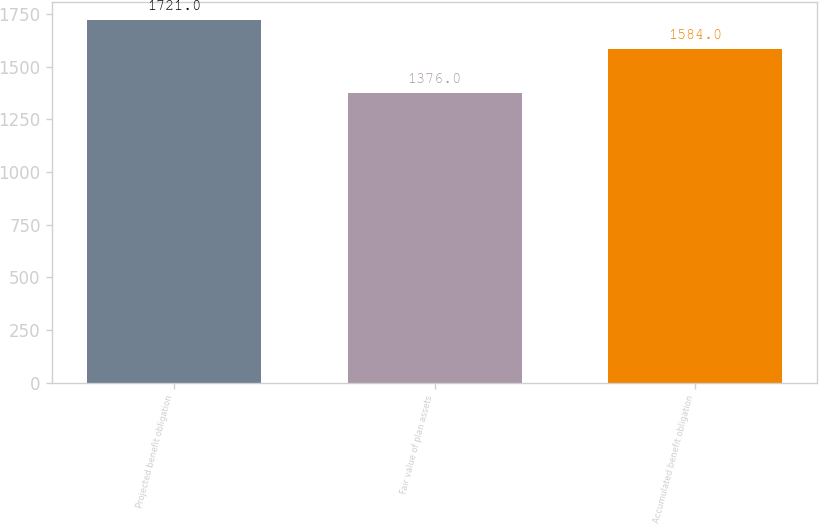<chart> <loc_0><loc_0><loc_500><loc_500><bar_chart><fcel>Projected benefit obligation<fcel>Fair value of plan assets<fcel>Accumulated benefit obligation<nl><fcel>1721<fcel>1376<fcel>1584<nl></chart> 